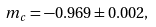Convert formula to latex. <formula><loc_0><loc_0><loc_500><loc_500>m _ { c } = - 0 . 9 6 9 \pm 0 . 0 0 2 ,</formula> 